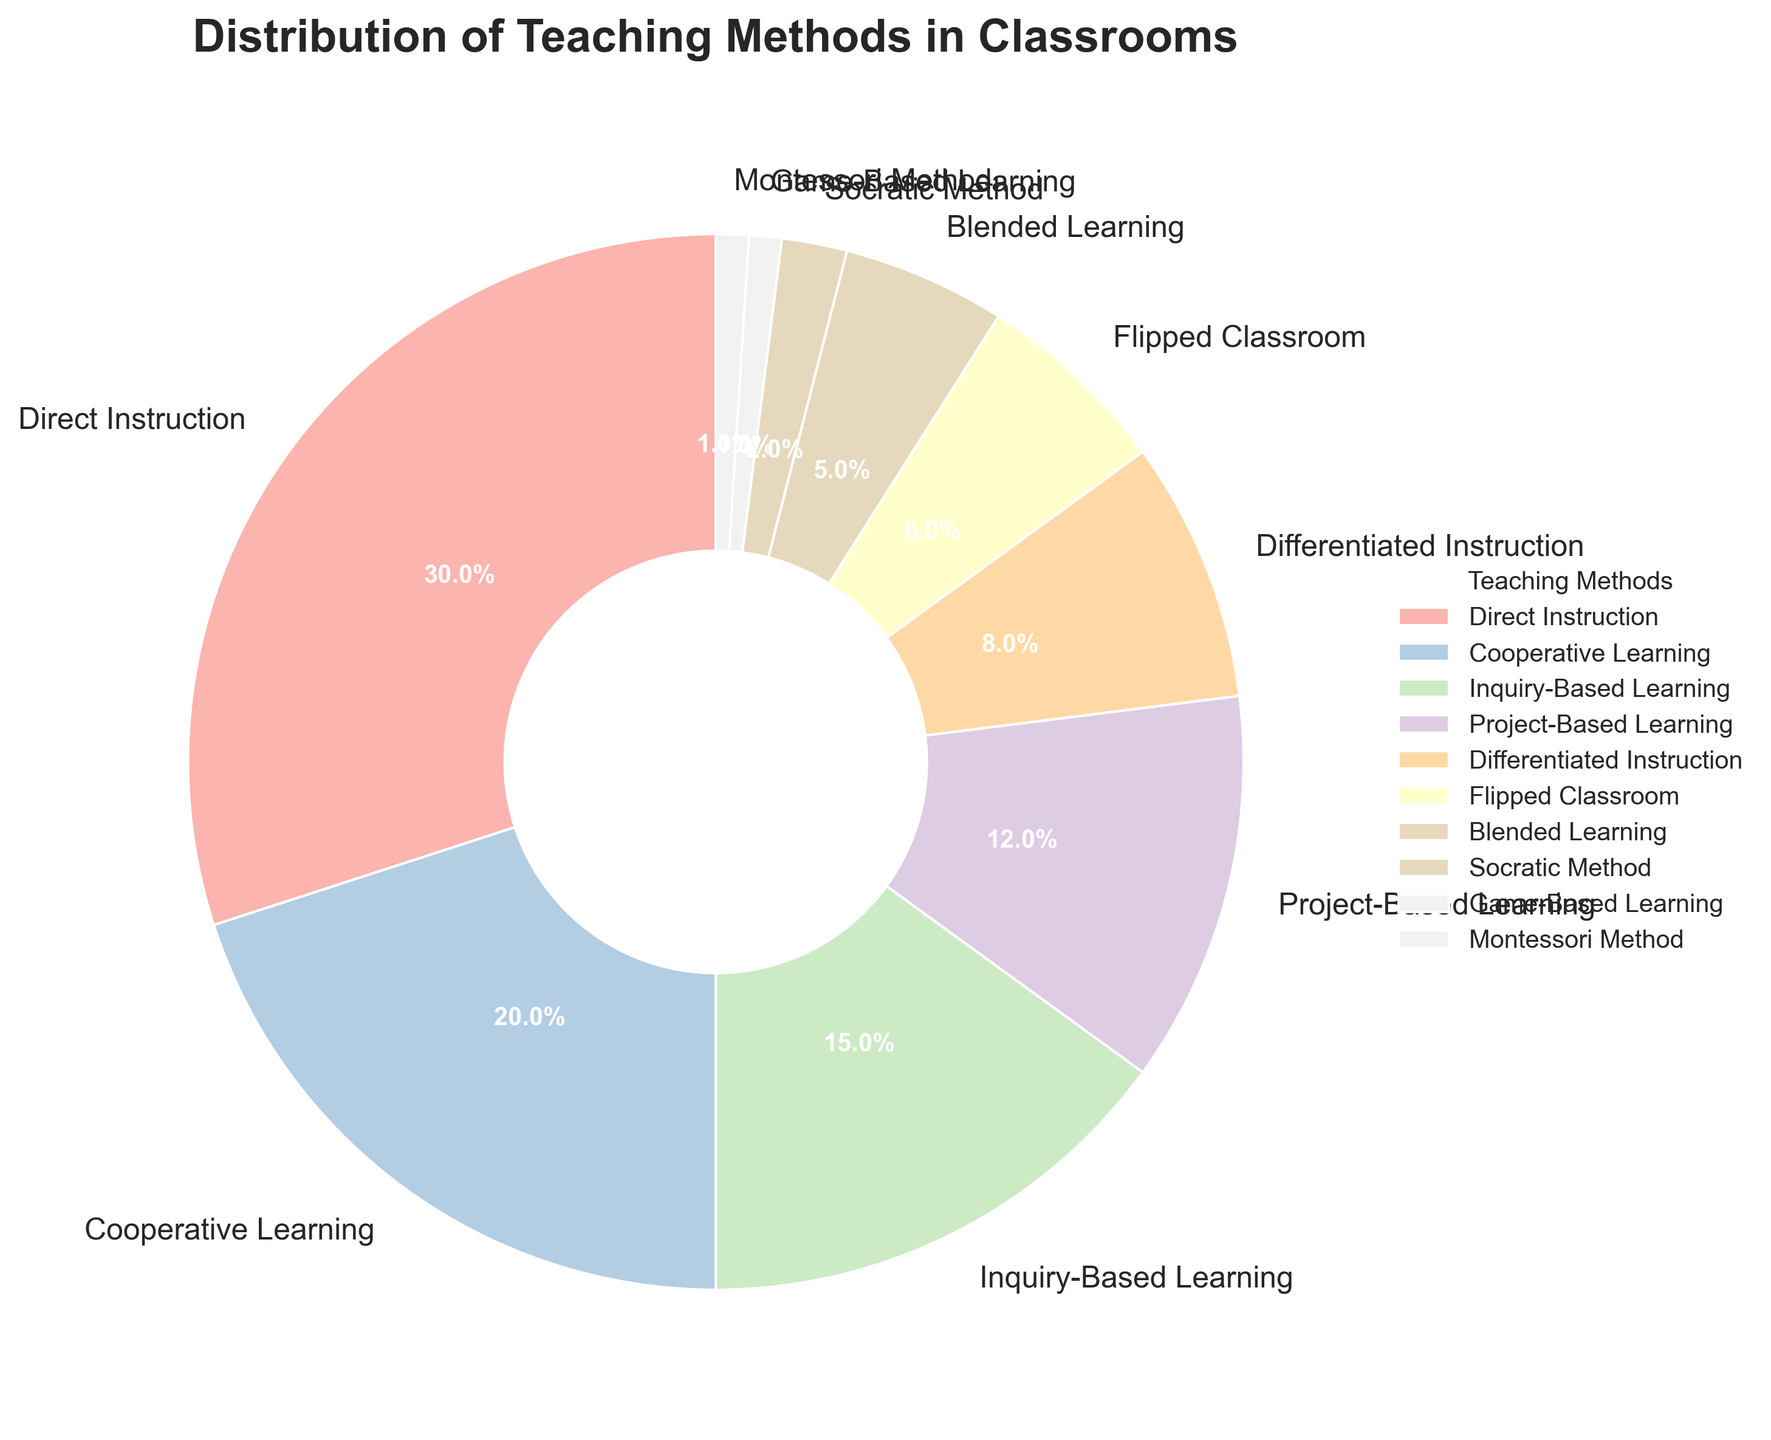Which teaching method is used most frequently in classrooms? The pie chart shows various teaching methods with their corresponding percentages. The largest wedge will indicate the most frequently used method. By observing the chart, Direct Instruction has the largest wedge with 30%.
Answer: Direct Instruction Which teaching method is least frequently used? The smallest wedge in the pie chart represents the least frequently used method. The chart shows that both Game-Based Learning and Montessori Method have the smallest wedges, each with 1%.
Answer: Game-Based Learning and Montessori Method How much more percentage does Direct Instruction have compared to Cooperative Learning? From the chart, Direct Instruction is 30% and Cooperative Learning is 20%. The difference is calculated as 30% - 20% = 10%.
Answer: 10% What is the combined percentage of Inquiry-Based Learning and Project-Based Learning? By identifying the respective wedges, Inquiry-Based Learning has 15% and Project-Based Learning has 12%. Adding these together gives 15% + 12% = 27%.
Answer: 27% Are there more methods that are used 10% or less, or more than 10%? We need to count the methods with percentages more than 10% and those with 10% or less. More than 10%: Direct Instruction, Cooperative Learning, Inquiry-Based Learning, Project-Based Learning (4 methods). 10% or less: Differentiated Instruction, Flipped Classroom, Blended Learning, Socratic Method, Game-Based Learning, Montessori Method (6 methods). There are more methods used 10% or less.
Answer: 10% or less Which methods together make up a third (33.3%) of the distribution? We need to select methods until their cumulative percentage is close to 33.3%. Direct Instruction (30%) + Socratic Method (2%) + Game-Based Learning (1%) + Montessori Method (1%) = 34%. This combination is the closest to 33.3%.
Answer: Direct Instruction, Socratic Method, Game-Based Learning, Montessori Method What is the second most common teaching method used? The second-largest wedge will represent this. Cooperative Learning has 20%, making it the second most common based on the pie chart.
Answer: Cooperative Learning Is the Flipped Classroom method used more often than Blended Learning? By comparing the wedges, Flipped Classroom has 6% while Blended Learning has 5%. Thus, Flipped Classroom is used more.
Answer: Yes Among the listed methods, which have a total percentage equal to or exceeding 60%? Summing up from the largest downward until we reach or exceed 60%. Direct Instruction (30%) + Cooperative Learning (20%) = 50%, adding Inquiry-Based Learning (15%) results in 65%. This combination exceeds 60%.
Answer: Direct Instruction, Cooperative Learning, Inquiry-Based Learning 